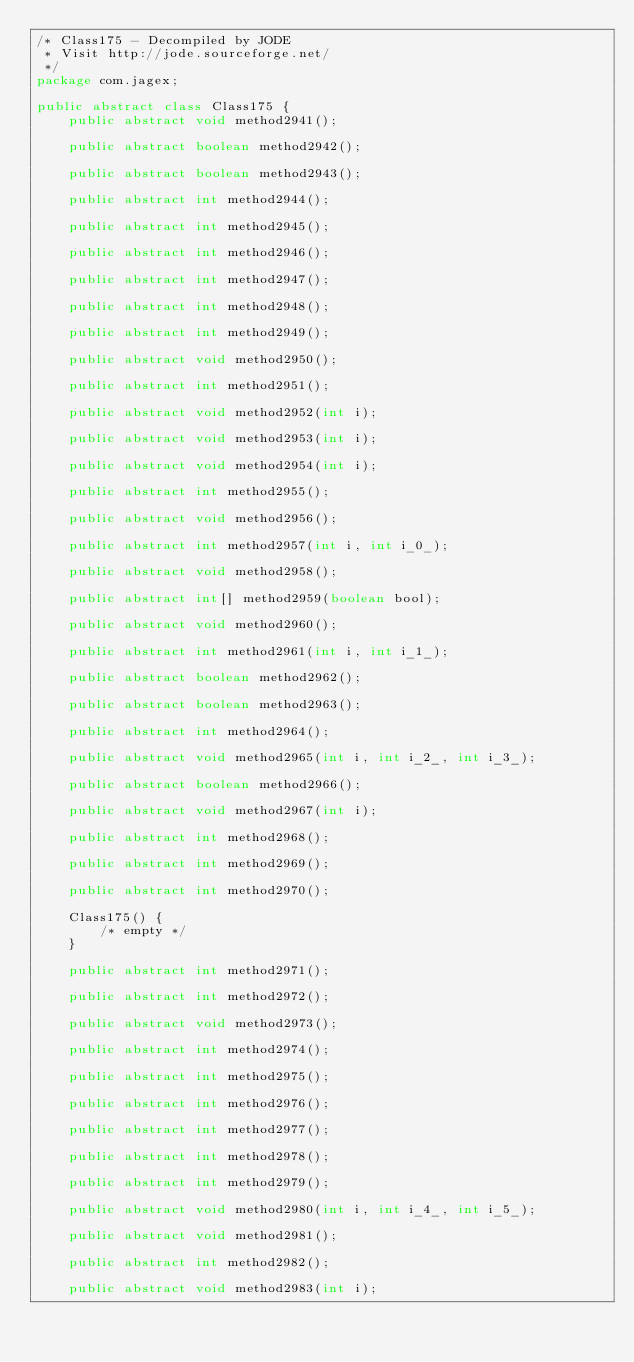Convert code to text. <code><loc_0><loc_0><loc_500><loc_500><_Java_>/* Class175 - Decompiled by JODE
 * Visit http://jode.sourceforge.net/
 */
package com.jagex;

public abstract class Class175 {
	public abstract void method2941();

	public abstract boolean method2942();

	public abstract boolean method2943();

	public abstract int method2944();

	public abstract int method2945();

	public abstract int method2946();

	public abstract int method2947();

	public abstract int method2948();

	public abstract int method2949();

	public abstract void method2950();

	public abstract int method2951();

	public abstract void method2952(int i);

	public abstract void method2953(int i);

	public abstract void method2954(int i);

	public abstract int method2955();

	public abstract void method2956();

	public abstract int method2957(int i, int i_0_);

	public abstract void method2958();

	public abstract int[] method2959(boolean bool);

	public abstract void method2960();

	public abstract int method2961(int i, int i_1_);

	public abstract boolean method2962();

	public abstract boolean method2963();

	public abstract int method2964();

	public abstract void method2965(int i, int i_2_, int i_3_);

	public abstract boolean method2966();

	public abstract void method2967(int i);

	public abstract int method2968();

	public abstract int method2969();

	public abstract int method2970();

	Class175() {
		/* empty */
	}

	public abstract int method2971();

	public abstract int method2972();

	public abstract void method2973();

	public abstract int method2974();

	public abstract int method2975();

	public abstract int method2976();

	public abstract int method2977();

	public abstract int method2978();

	public abstract int method2979();

	public abstract void method2980(int i, int i_4_, int i_5_);

	public abstract void method2981();

	public abstract int method2982();

	public abstract void method2983(int i);
</code> 